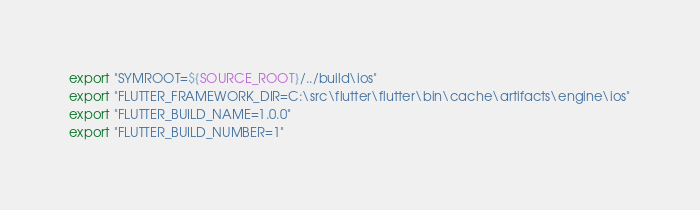<code> <loc_0><loc_0><loc_500><loc_500><_Bash_>export "SYMROOT=${SOURCE_ROOT}/../build\ios"
export "FLUTTER_FRAMEWORK_DIR=C:\src\flutter\flutter\bin\cache\artifacts\engine\ios"
export "FLUTTER_BUILD_NAME=1.0.0"
export "FLUTTER_BUILD_NUMBER=1"
</code> 